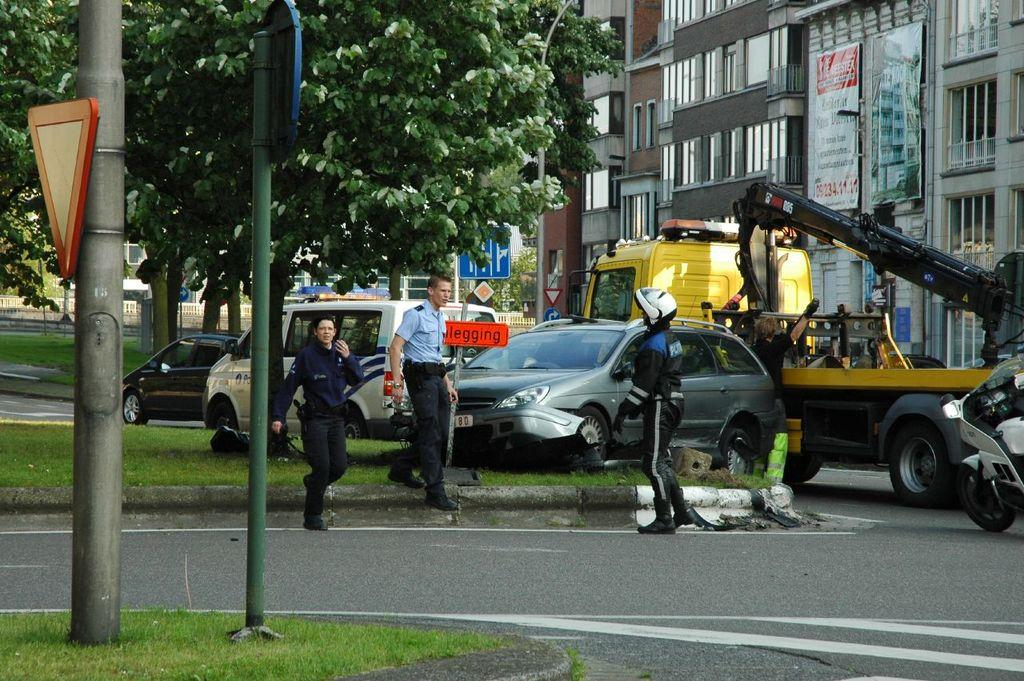How many people are in the image? There are people in the image, but the exact number is not specified. What are some of the people doing in the image? Some people are walking in the image. What types of vehicles can be seen in the image? There are vehicles in the image, but the specific types are not mentioned. What structures are present in the image? There are poles, sign boards, trees, buildings, banners, glass, walls, and roads in the image. What type of ground surface is visible in the image? There is grass in the image. How many babies are rolling on the grass in the image? There is no mention of babies or rolling in the image; it only states that there are people walking and grass is visible. 